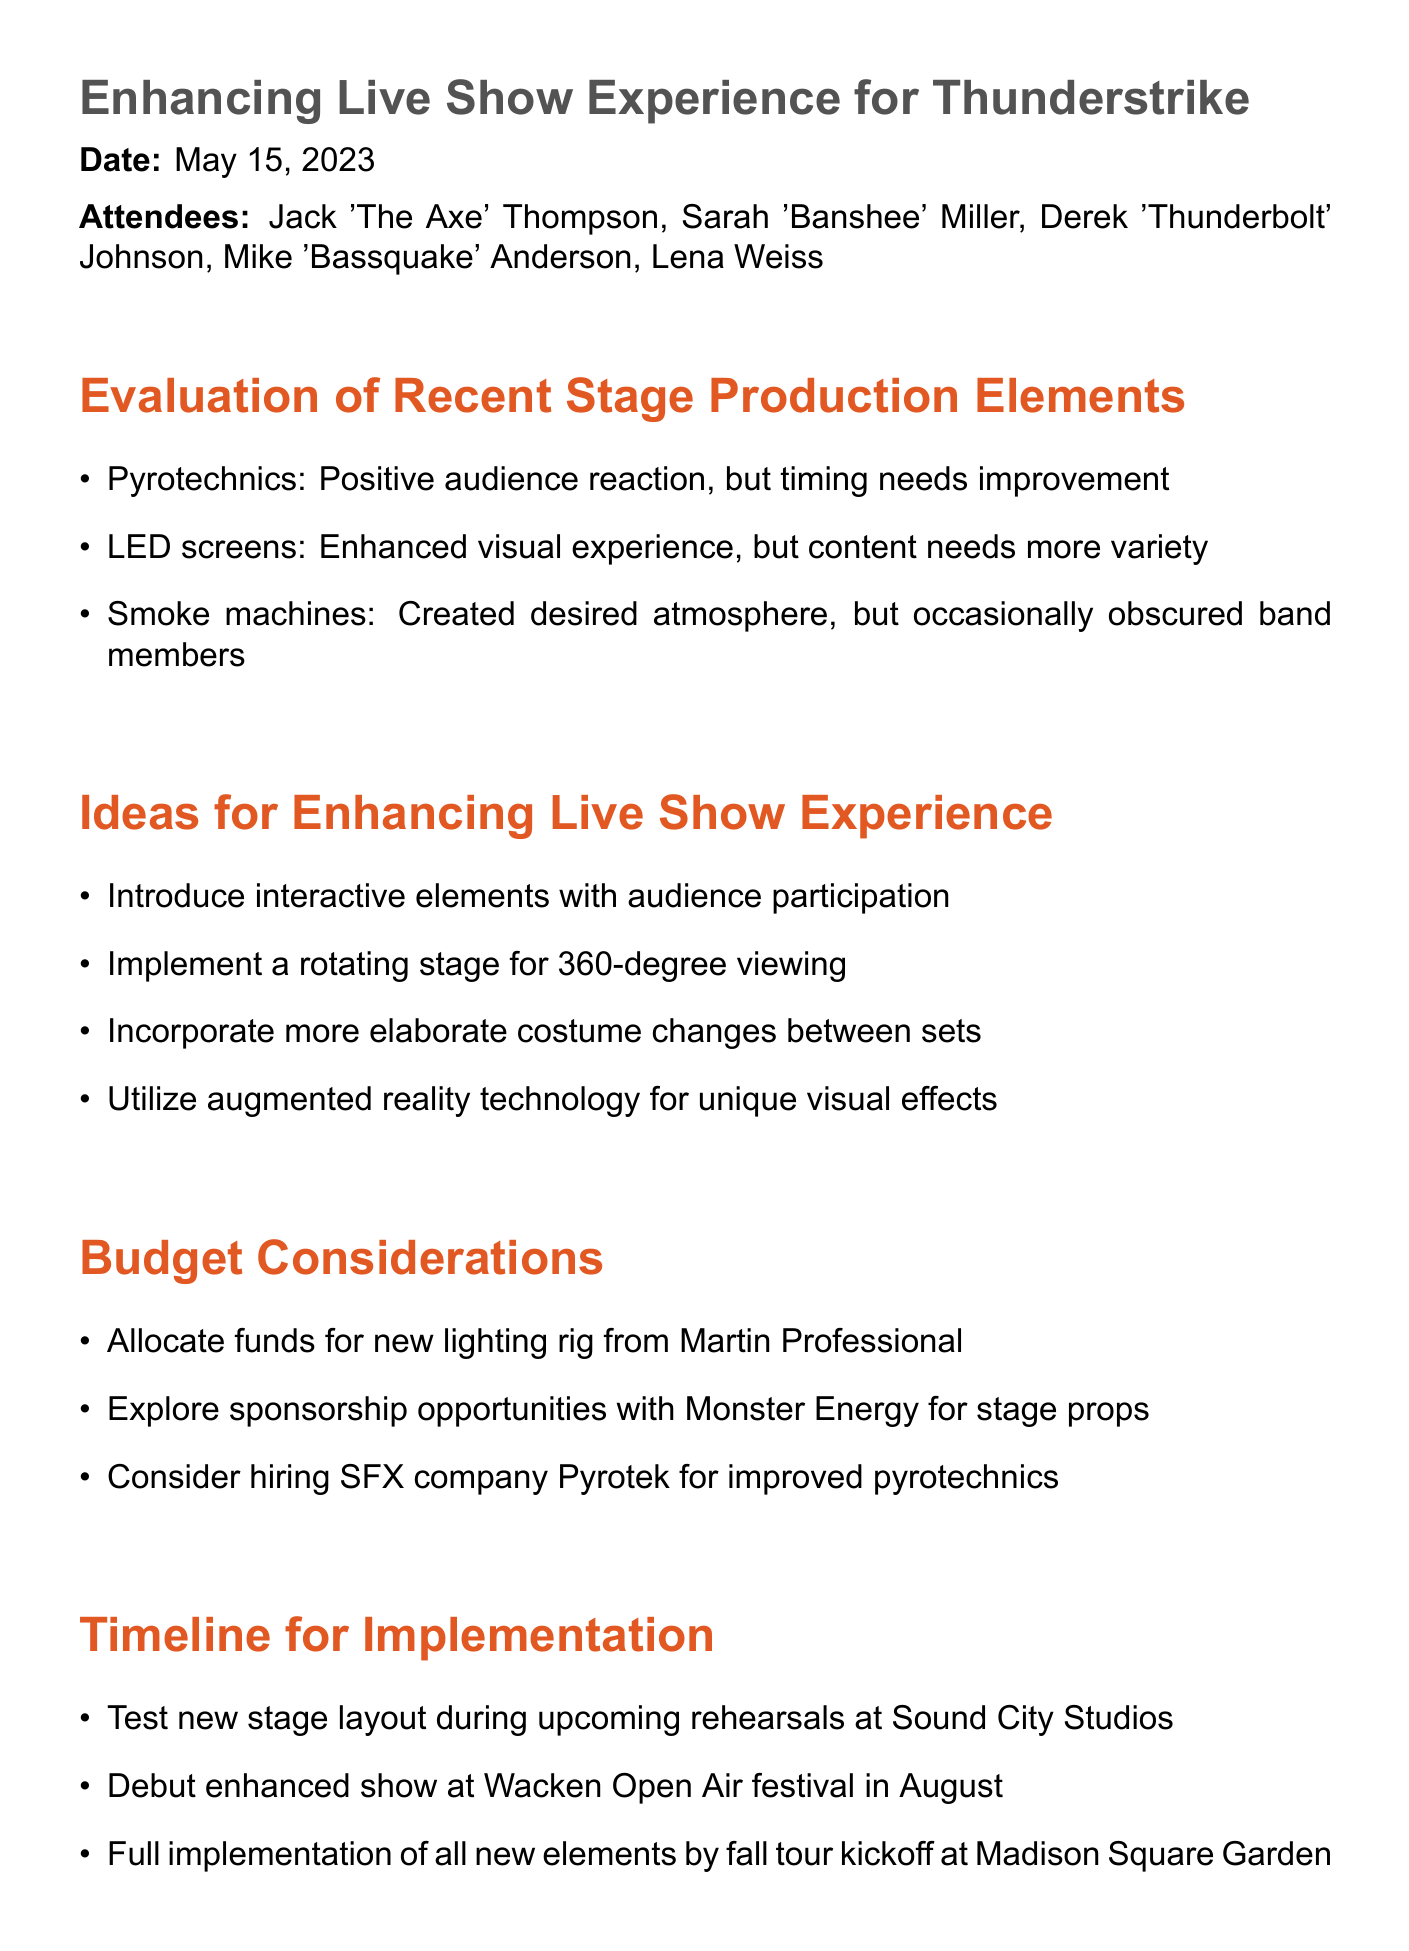What is the date of the meeting? The date of the meeting is explicitly mentioned in the document.
Answer: May 15, 2023 Who is the lead guitarist of Thunderstrike? The document lists attendees, identifying Jack 'The Axe' Thompson as the lead guitarist.
Answer: Jack 'The Axe' Thompson What was a positive aspect of the pyrotechnics? The document states that there was a positive audience reaction to the pyrotechnics.
Answer: Positive audience reaction What technology is suggested for unique visual effects? The document proposes the use of augmented reality technology.
Answer: Augmented reality technology What is the first action item listed in the meeting minutes? The document outlines several action items, with the first being related to Sarah contacting a visual effects company.
Answer: Sarah to contact AR company Moment Factory for visual effects proposal What festival will debut the enhanced show? The document highlights the Wacken Open Air festival as the debut for the enhanced show.
Answer: Wacken Open Air festival What is one of the budget considerations mentioned? The document includes various budget considerations, one of which relates to a new lighting rig.
Answer: Allocate funds for new lighting rig from Martin Professional How many action items are listed in total? The document lists four specific action items.
Answer: Four 